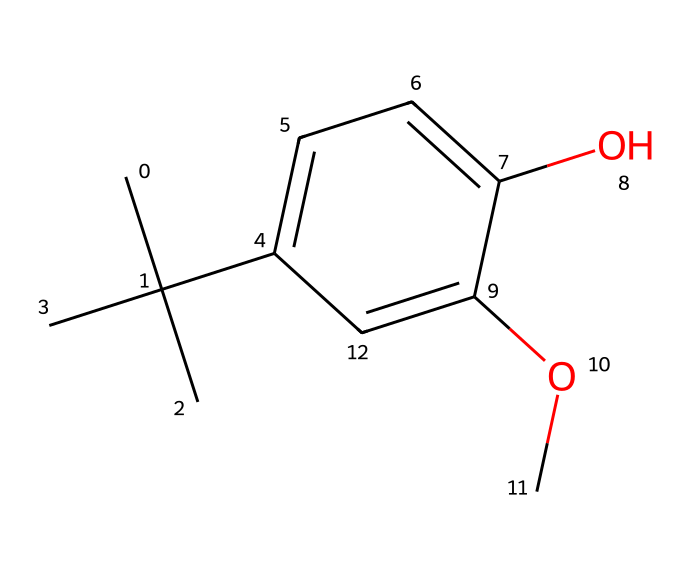How many carbon atoms are present in the structure of BHA? By examining the SMILES representation, we can identify the carbon atoms. Each "C" indicates a carbon atom, and the branched structure indicates that there are additional carbon atoms connected through branches and rings. Counting them gives a total of 11 carbon atoms.
Answer: 11 What type of functional group is present in BHA? Looking at the structure, we notice that there is a hydroxyl (-OH) group attached to the aromatic ring, which characterizes it as a phenolic compound. The presence of both the -OH and the methoxy (-OCH3) group further establishes its identity.
Answer: phenolic How many oxygen atoms are present in the structure of BHA? From the structure, we observe two distinct functional groups containing oxygen: one from the hydroxyl group and one from the methoxy group. Thus, there are a total of 2 oxygen atoms counted in the structure.
Answer: 2 What is the overall molecular formula of BHA? By summing the quantities of each type of atom identified in the structure (C, H, and O), we can derive the molecular formula. The calculated counts yield C11H14O2 as the final molecular formula.
Answer: C11H14O2 What is the primary role of BHA in food preservation? BHA serves a crucial role as an antioxidant in food preservation, primarily functioning to inhibit the oxidation of lipids and prevent rancidity, thereby prolonging shelf life.
Answer: antioxidant What is the significance of the branched carbon chain in BHA? The branched carbon chain in the structure contributes to the steric bulk and hydrophobic characteristics, enhancing the effectiveness of BHA as an antioxidant by contributing to its solubility and distribution in lipid matrices.
Answer: steric bulk How does BHA interact with free radicals? BHA interacts with free radicals through its phenolic hydroxyl group, which donates hydrogen atoms to neutralize radicals, thus preventing oxidative damage in food products.
Answer: donates hydrogen 